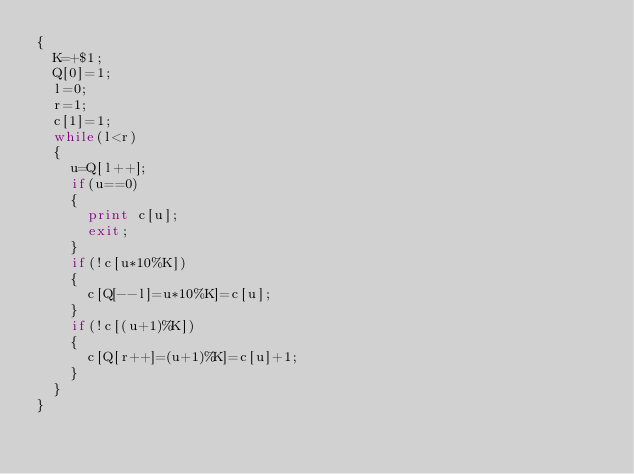<code> <loc_0><loc_0><loc_500><loc_500><_Awk_>{
	K=+$1;
	Q[0]=1;
	l=0;
	r=1;
	c[1]=1;
	while(l<r)
	{
		u=Q[l++];
		if(u==0)
		{
			print c[u];
			exit;
		}
		if(!c[u*10%K])
		{
			c[Q[--l]=u*10%K]=c[u];
		}
		if(!c[(u+1)%K])
		{
			c[Q[r++]=(u+1)%K]=c[u]+1;
		}
	}
}</code> 